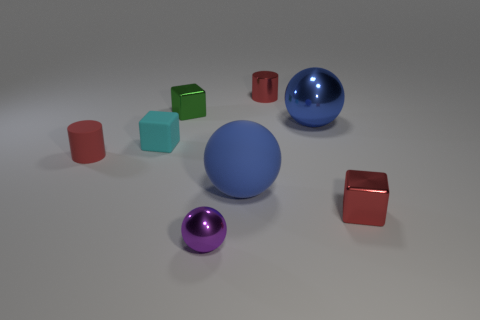What number of other things are there of the same color as the metallic cylinder?
Ensure brevity in your answer.  2. How big is the red shiny object that is in front of the shiny block to the left of the small ball?
Provide a short and direct response. Small. Are there more blue matte things that are behind the small matte block than large rubber balls on the right side of the blue rubber ball?
Give a very brief answer. No. What number of blocks are large blue shiny things or tiny purple objects?
Keep it short and to the point. 0. There is a cyan object that is in front of the large metal ball; is it the same shape as the purple metallic object?
Provide a succinct answer. No. The large rubber ball has what color?
Keep it short and to the point. Blue. The big metal thing that is the same shape as the large rubber thing is what color?
Your response must be concise. Blue. What number of other purple things have the same shape as the small purple object?
Provide a succinct answer. 0. What number of things are tiny purple metallic things or small cubes that are to the left of the tiny green block?
Offer a very short reply. 2. There is a matte cube; does it have the same color as the large sphere that is behind the blue matte object?
Make the answer very short. No. 